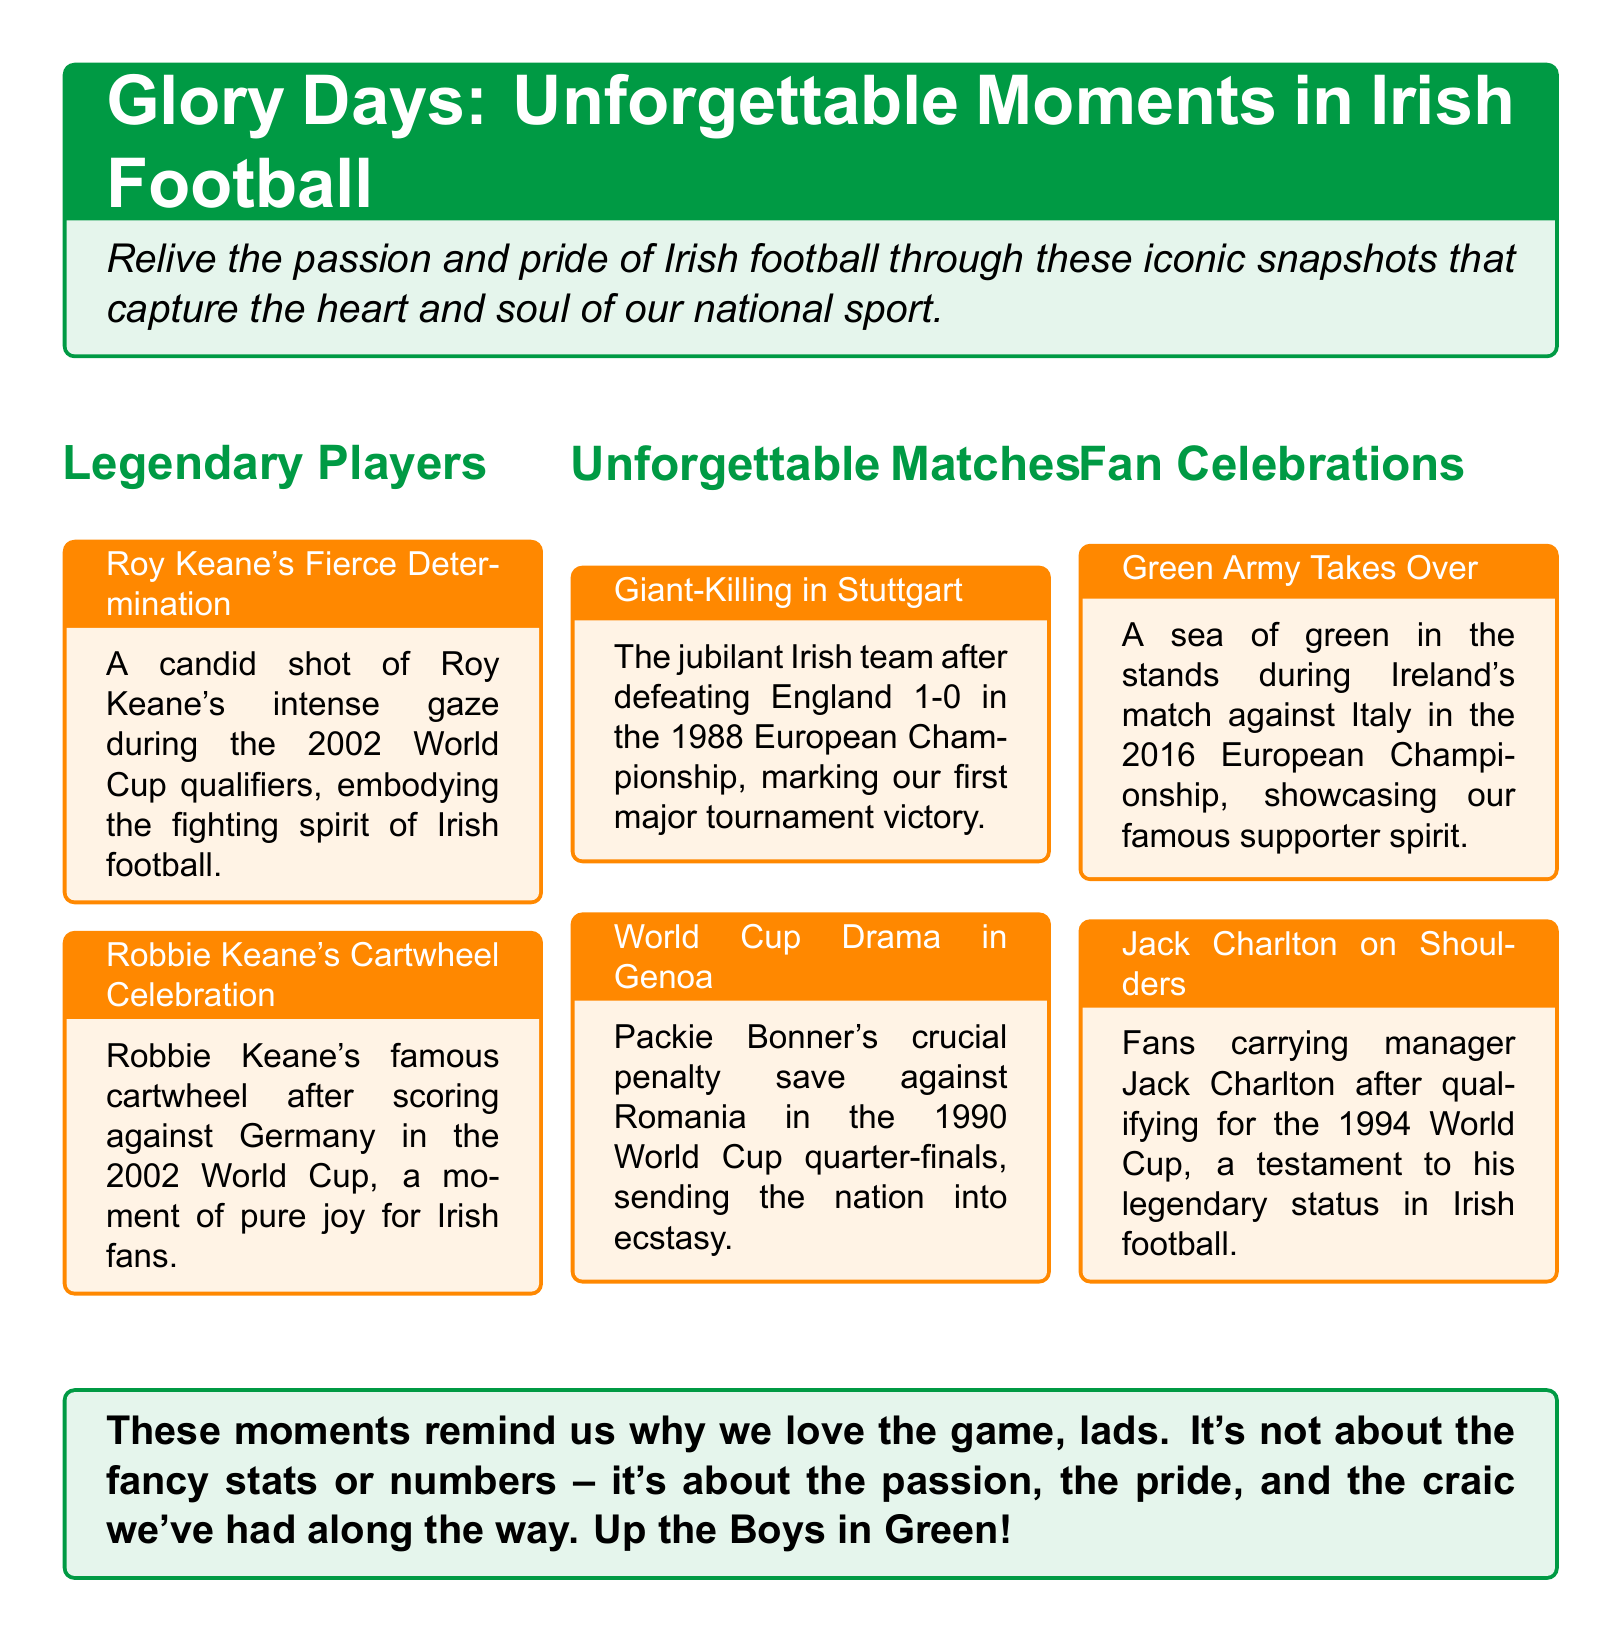What is the title of the catalog? The title is prominently displayed at the top of the document, which is "Glory Days: Unforgettable Moments in Irish Football."
Answer: Glory Days: Unforgettable Moments in Irish Football Who is featured in the photograph titled "Roy Keane's Fierce Determination"? The document indicates that Roy Keane is the focus of this particular photograph, capturing his intense gaze.
Answer: Roy Keane In which tournament did Robbie Keane perform his famous cartwheel celebration? The document states that this celebration took place during the 2002 World Cup.
Answer: 2002 World Cup What significant event is described in "Giant-Killing in Stuttgart"? The moment refers to Ireland's famous victory over England, marking a milestone in their tournament history.
Answer: Defeating England 1-0 Who made a crucial penalty save against Romania? The document identifies the player who achieved this feat as Packie Bonner during the 1990 World Cup.
Answer: Packie Bonner What year did fans carry Jack Charlton on their shoulders? According to the document, this event occurred after qualifying for the 1994 World Cup.
Answer: 1994 What color is associated with the "Green Army Takes Over"? The photograph describes a vibrant display of supporters dressed in the national colors during the match.
Answer: Green What is the main theme of the catalog? The catalog revolves around showcasing memorable moments and the emotional connection fans have with Irish football.
Answer: Memorable moments 